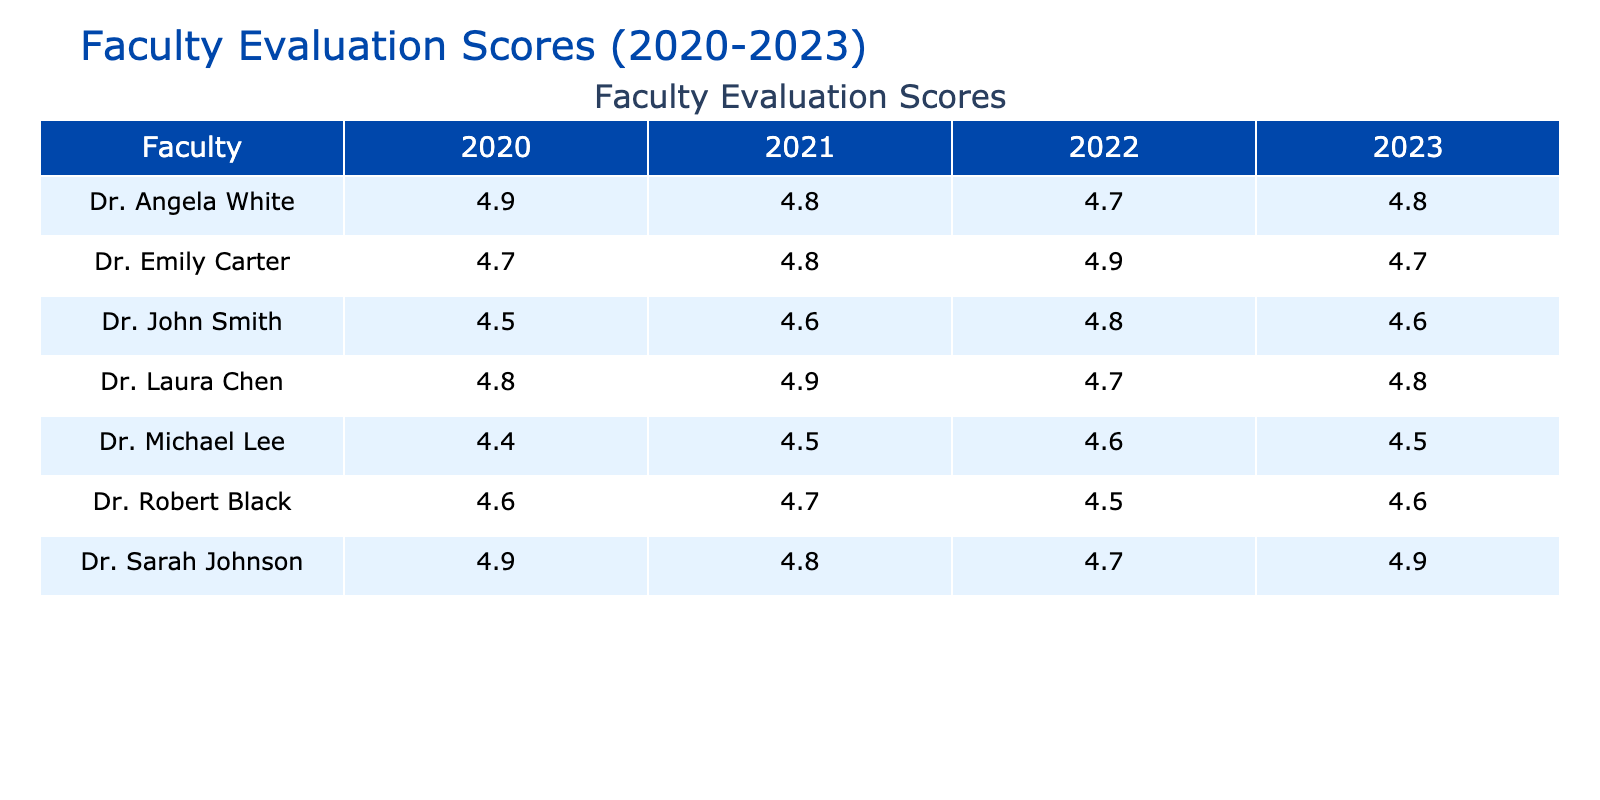What was Dr. Emily Carter's evaluation score in 2021? The table lists Dr. Emily Carter's evaluation score for 2021 as 4.8.
Answer: 4.8 What is the evaluation score of Dr. John Smith in 2022? According to the table, Dr. John Smith received an evaluation score of 4.8 in 2022.
Answer: 4.8 Which faculty had the highest evaluation score in 2020? Looking at the 2020 scores, Dr. Sarah Johnson had the highest score of 4.9.
Answer: Dr. Sarah Johnson What is the average evaluation score of Dr. Laura Chen over the four years? Summing Dr. Laura Chen's scores from 2020 to 2023 gives us 4.8 + 4.9 + 4.7 + 4.8 = 19.2. Dividing by 4 yields an average of 19.2 / 4 = 4.8.
Answer: 4.8 Did Dr. Michael Lee's evaluation score improve from 2020 to 2022? Dr. Michael Lee's scores were 4.4 in 2020, 4.5 in 2021, and 4.6 in 2022, indicating a continuous improvement over the three years.
Answer: Yes What was the trend in evaluation scores for Dr. Angela White from 2020 to 2023? Dr. Angela White's scores were 4.9, 4.8, 4.7, and 4.8 over the years, showing a decrease from 2020 to 2022 followed by a slight increase in 2023.
Answer: Decrease then increase Which faculty consistently received the highest scores over the years? By comparing scores across all years, Dr. Sarah Johnson had the most consistent high evaluations, with scores ranging from 4.7 to 4.9, compared to others who had lower scores in some years.
Answer: Dr. Sarah Johnson What is the difference in evaluation scores between Dr. Robert Black in 2021 and 2022? Dr. Robert Black's score in 2021 was 4.7 and in 2022 it was 4.5. The difference is 4.7 - 4.5 = 0.2.
Answer: 0.2 Which faculty had the most stable evaluation scores with the smallest range over the years? Analyzing all faculty scores, Dr. Laura Chen had scores of 4.8, 4.9, 4.7, and 4.8, giving a range of only 0.2 (highest score 4.9 - lowest score 4.7), indicating stability.
Answer: Dr. Laura Chen What was the evaluation score of Dr. Sarah Johnson in 2023, and how does it compare to her score from 2021? Dr. Sarah Johnson scored 4.9 in 2023 and 4.8 in 2021. This shows that her score improved by 0.1 over that period.
Answer: 4.9, improved by 0.1 